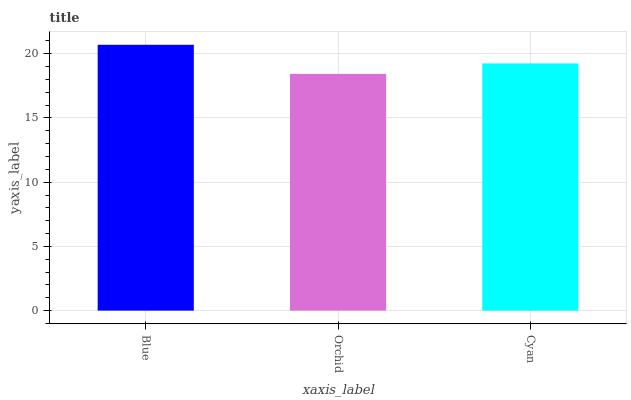Is Orchid the minimum?
Answer yes or no. Yes. Is Blue the maximum?
Answer yes or no. Yes. Is Cyan the minimum?
Answer yes or no. No. Is Cyan the maximum?
Answer yes or no. No. Is Cyan greater than Orchid?
Answer yes or no. Yes. Is Orchid less than Cyan?
Answer yes or no. Yes. Is Orchid greater than Cyan?
Answer yes or no. No. Is Cyan less than Orchid?
Answer yes or no. No. Is Cyan the high median?
Answer yes or no. Yes. Is Cyan the low median?
Answer yes or no. Yes. Is Orchid the high median?
Answer yes or no. No. Is Blue the low median?
Answer yes or no. No. 